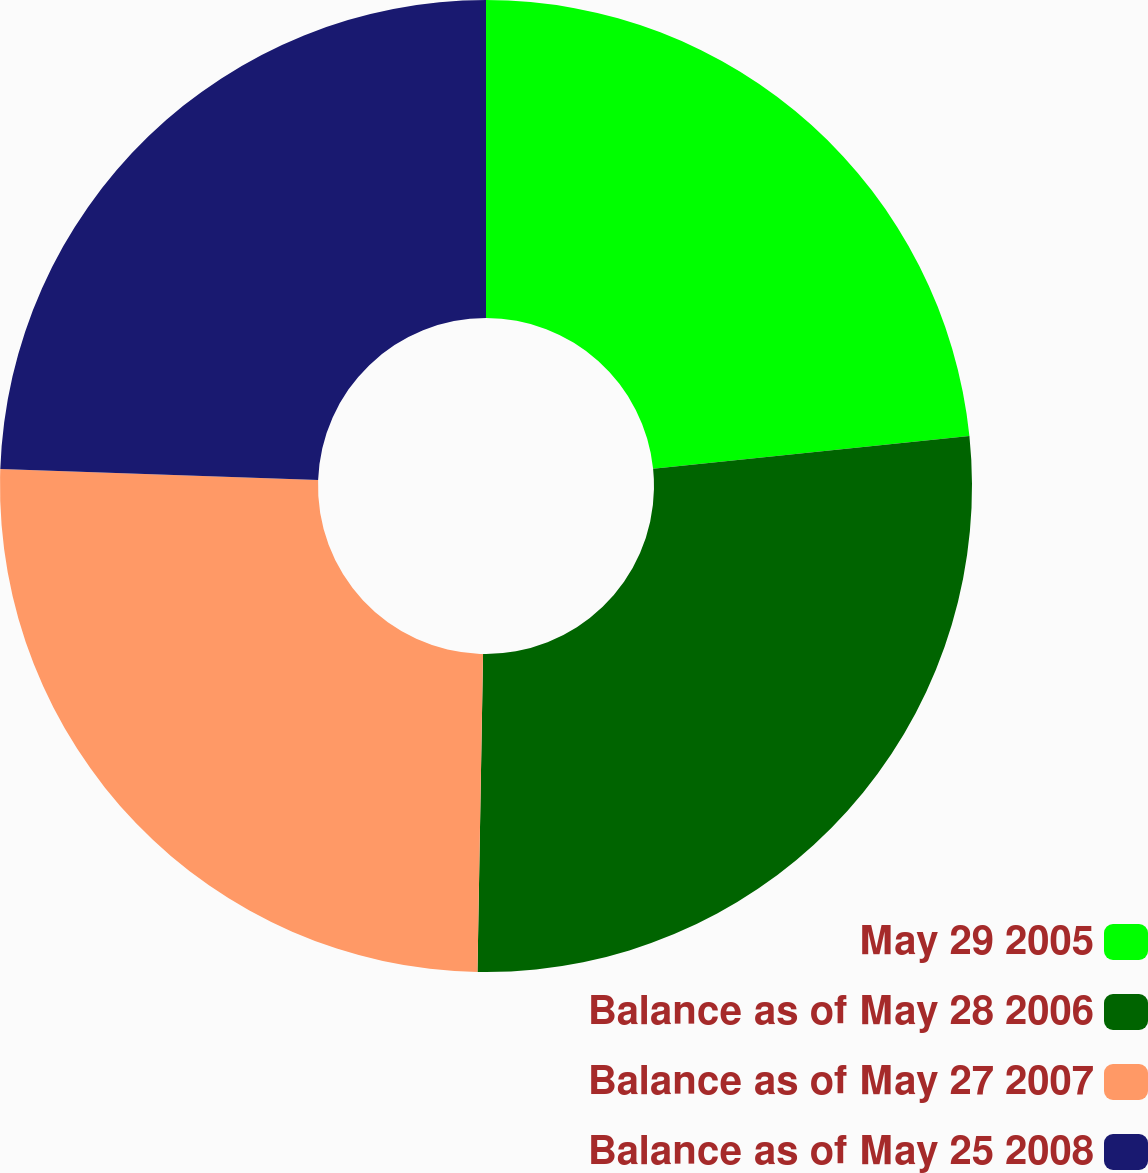Convert chart to OTSL. <chart><loc_0><loc_0><loc_500><loc_500><pie_chart><fcel>May 29 2005<fcel>Balance as of May 28 2006<fcel>Balance as of May 27 2007<fcel>Balance as of May 25 2008<nl><fcel>23.36%<fcel>26.92%<fcel>25.28%<fcel>24.44%<nl></chart> 